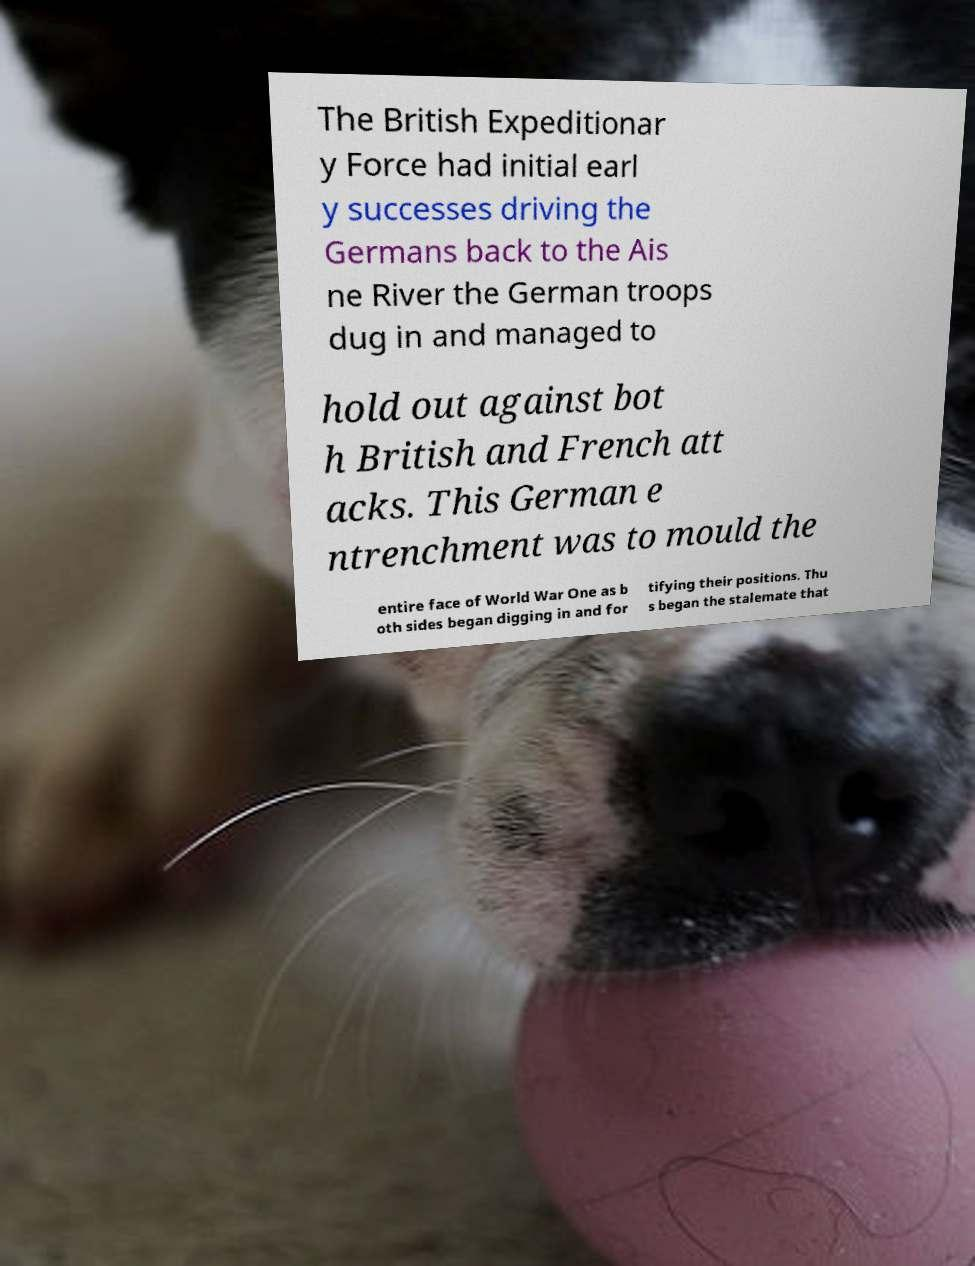Please identify and transcribe the text found in this image. The British Expeditionar y Force had initial earl y successes driving the Germans back to the Ais ne River the German troops dug in and managed to hold out against bot h British and French att acks. This German e ntrenchment was to mould the entire face of World War One as b oth sides began digging in and for tifying their positions. Thu s began the stalemate that 